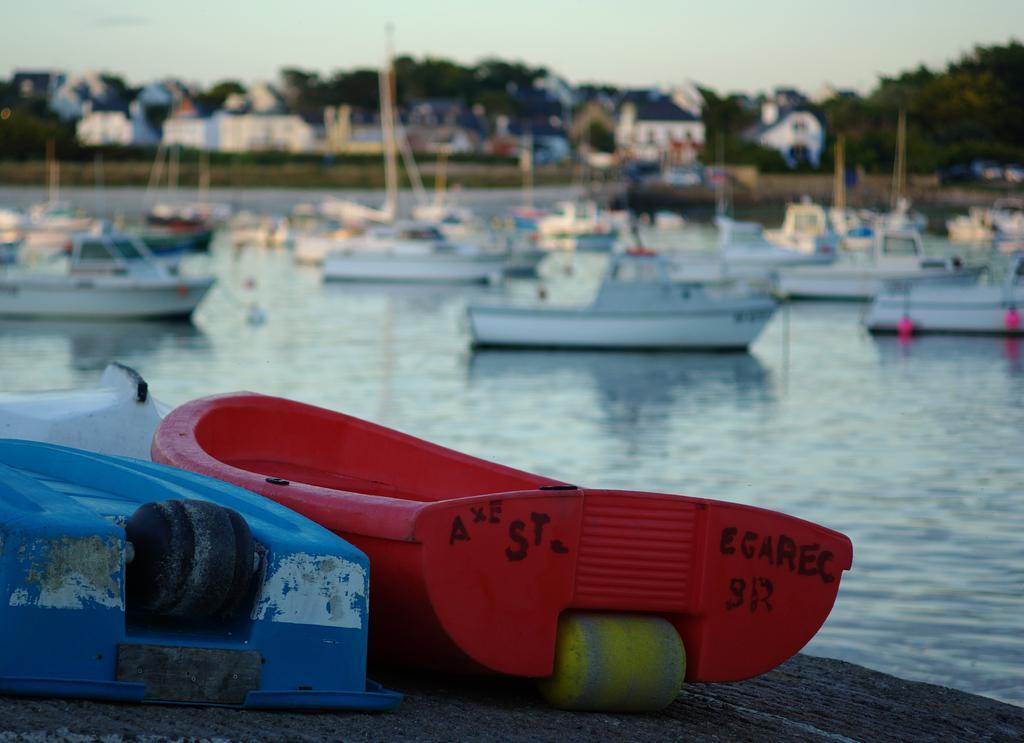In one or two sentences, can you explain what this image depicts? In this image we can see red and blue boats are kept on a wooden surface. The background of the image is slightly blurred, where we can see a few more boats are floating on the water, we can see houses, trees and the sky. 